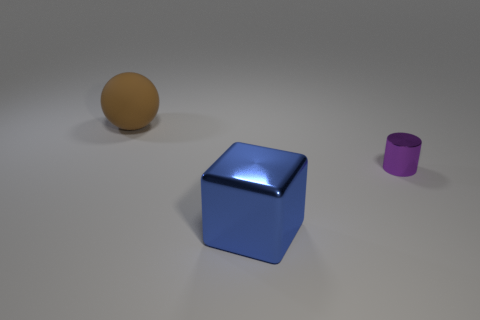Add 1 green metal cylinders. How many objects exist? 4 Subtract 0 gray balls. How many objects are left? 3 Subtract all cylinders. How many objects are left? 2 Subtract 1 blocks. How many blocks are left? 0 Subtract all purple balls. Subtract all green cubes. How many balls are left? 1 Subtract all tiny red objects. Subtract all large rubber things. How many objects are left? 2 Add 2 rubber spheres. How many rubber spheres are left? 3 Add 1 tiny yellow balls. How many tiny yellow balls exist? 1 